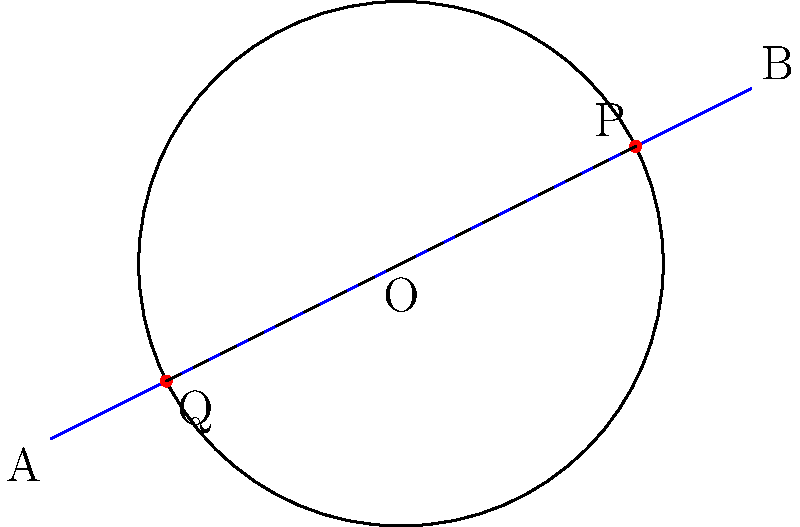As a GIS analyst and drone enthusiast, you're planning a flight path that intersects a circular no-fly zone. The no-fly zone has a radius of 3 km centered at the origin O(0,0). Your planned flight path is a straight line from point A(-4,-2) to point B(4,2). What is the length of the flight path segment PQ that lies within the no-fly zone? To solve this problem, we'll follow these steps:

1) First, we need to find the coordinates of points P and Q where the flight path intersects the circular no-fly zone. We can use the equation of the circle and the equation of the line to find these points.

2) The equation of the circle is: $x^2 + y^2 = 3^2 = 9$

3) The equation of the line AB can be found using the point-slope form:
   $y - y_1 = m(x - x_1)$, where $m = \frac{y_2 - y_1}{x_2 - x_1} = \frac{2 - (-2)}{4 - (-4)} = \frac{1}{2}$
   
   So, the equation of the line is: $y = \frac{1}{2}x + 0$

4) Substituting this into the circle equation:
   $x^2 + (\frac{1}{2}x)^2 = 9$
   $x^2 + \frac{1}{4}x^2 = 9$
   $\frac{5}{4}x^2 = 9$
   $x^2 = \frac{36}{5}$
   $x = \pm \frac{6\sqrt{5}}{5}$

5) The x-coordinates of P and Q are $-\frac{6\sqrt{5}}{5}$ and $\frac{6\sqrt{5}}{5}$ respectively.

6) We can find the y-coordinates by substituting these x-values into the line equation:
   $y = \frac{1}{2}(-\frac{6\sqrt{5}}{5}) = -\frac{3\sqrt{5}}{5}$ for P
   $y = \frac{1}{2}(\frac{6\sqrt{5}}{5}) = \frac{3\sqrt{5}}{5}$ for Q

7) So, P $(-\frac{6\sqrt{5}}{5}, -\frac{3\sqrt{5}}{5})$ and Q $(\frac{6\sqrt{5}}{5}, \frac{3\sqrt{5}}{5})$

8) The length of PQ can be found using the distance formula:
   $PQ = \sqrt{(x_2-x_1)^2 + (y_2-y_1)^2}$
   $= \sqrt{(\frac{6\sqrt{5}}{5} - (-\frac{6\sqrt{5}}{5}))^2 + (\frac{3\sqrt{5}}{5} - (-\frac{3\sqrt{5}}{5}))^2}$
   $= \sqrt{(\frac{12\sqrt{5}}{5})^2 + (\frac{6\sqrt{5}}{5})^2}$
   $= \sqrt{\frac{288}{25} + \frac{72}{25}} = \sqrt{\frac{360}{25}} = \frac{6\sqrt{10}}{5}$

Therefore, the length of the flight path segment PQ within the no-fly zone is $\frac{6\sqrt{10}}{5}$ km.
Answer: $\frac{6\sqrt{10}}{5}$ km 